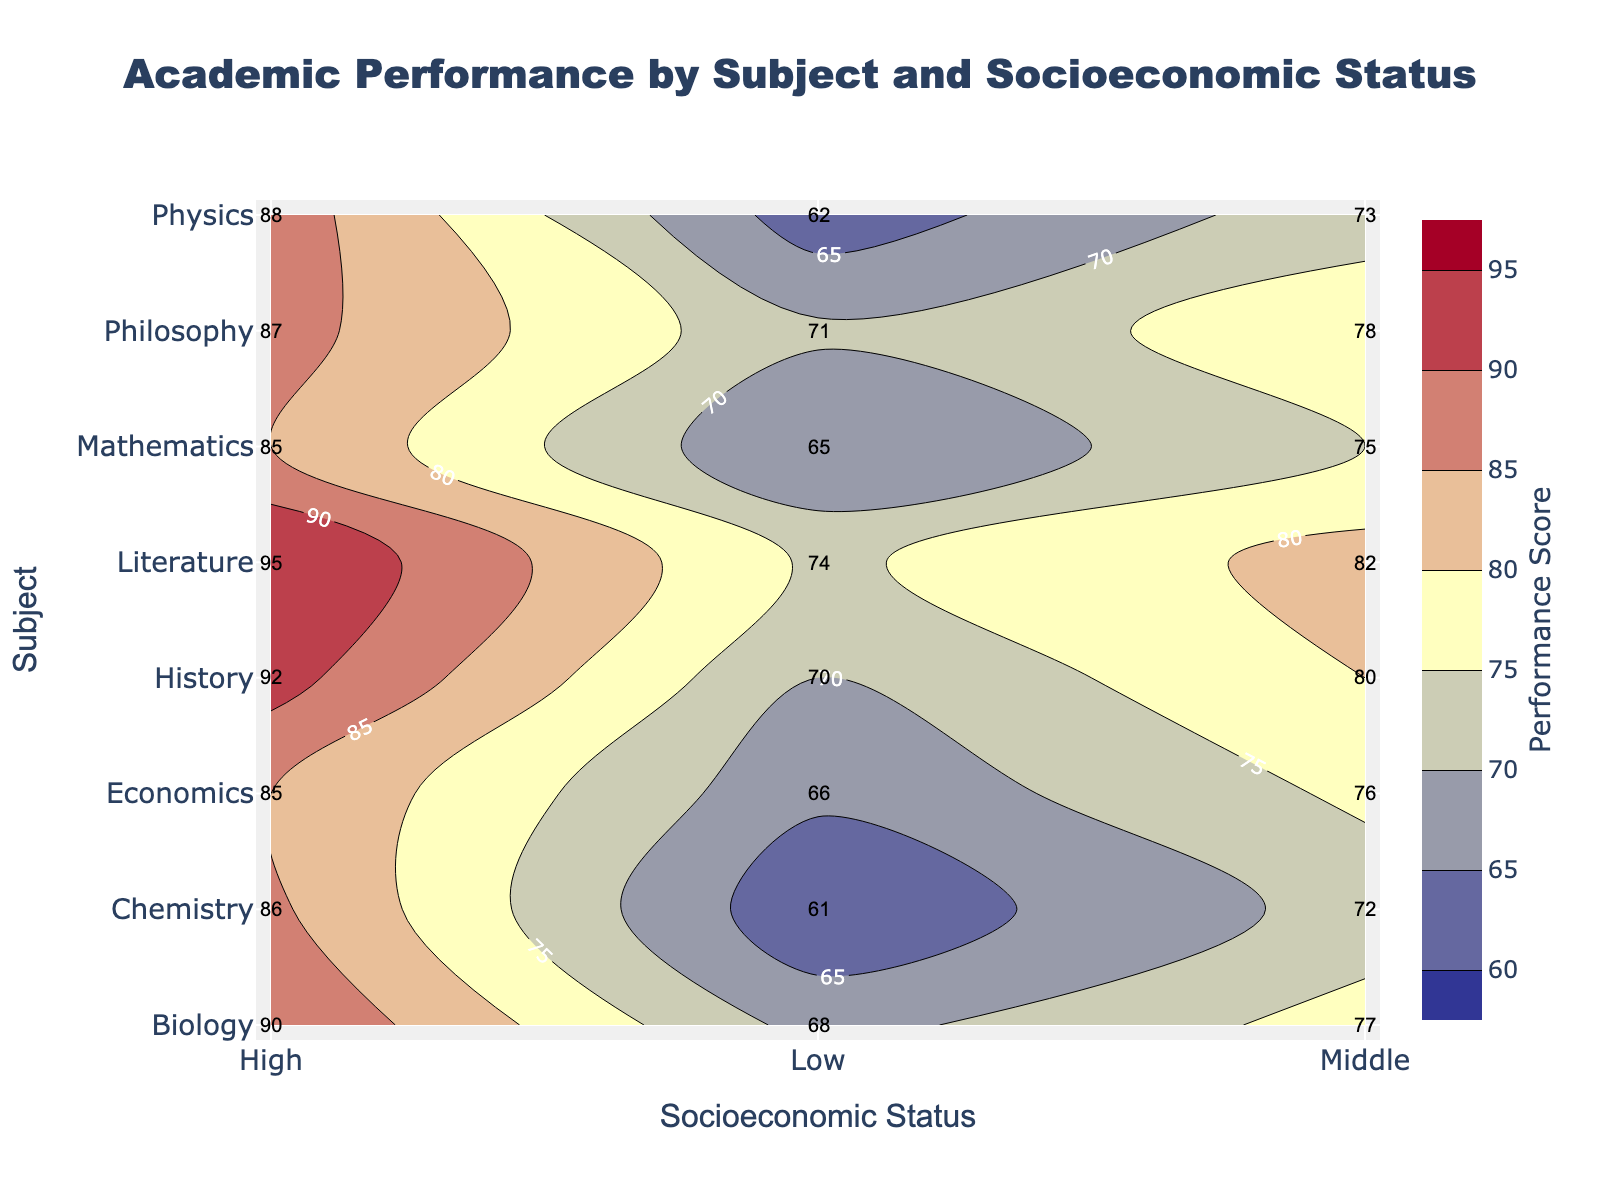What is the title of the figure? The title is usually located at the top of the figure, centered, and clearly labeled. In this figure, the title is "Academic Performance by Subject and Socioeconomic Status".
Answer: Academic Performance by Subject and Socioeconomic Status What are the x-axis and y-axis labels? The x-axis and y-axis labels are typically found near the respective axes. The x-axis is labeled "Socioeconomic Status," and the y-axis is labeled "Subject."
Answer: Socioeconomic Status, Subject What is the highest performance score observed in the figure? By looking for the highest contour label in the figure, which corresponds to the maximum value, we see that the highest performance score is 95 in the field of Literature for the High socioeconomic status.
Answer: 95 Which subject shows the least performance score for low socioeconomic status? By examining the contour plot for the "Low" socioeconomic status and comparing the values, Chemistry shows the least performance score, which is 61.
Answer: Chemistry Which socioeconomic status has the largest range of performance scores across all subjects? Calculate the performance score range for each socioeconomic status. For "Low": [70 (History) - 61 (Chemistry)] = 9. For "Middle": [82 (Literature) - 72 (Chemistry)] = 10. For "High": [95 (Literature) - 85 (Mathematics, Economics)] = 10. Both "Middle" and "High" have a range of 10.
Answer: Middle, High What is the overall trend in academic performance across different socioeconomic statuses? Observing the contour lines, the performance scores show a general upward trend from Low to High socioeconomic status across all subjects, meaning students from higher socioeconomic backgrounds tend to perform better academically.
Answer: Upward trend Between History and Physics, which subject shows the greater improvement in performance score moving from low to high socioeconomic status? The improvement in History is from 70 to 92, an increase of 22 points. In Physics, the increase is from 62 to 88, an increase of 26 points. Physics shows the greater improvement.
Answer: Physics How does the performance in Mathematics compare to Literature for middle socioeconomic status? For middle socioeconomic status, Mathematics has a score of 75, while Literature has a score of 82. Literature has a higher performance score.
Answer: Literature What is the average performance score for low socioeconomic status across all subjects? Sum the scores for low socioeconomic status (65 + 62 + 68 + 61 + 70 + 74 + 71 + 66) and divide by the number of scores (8). [(65 + 62 + 68 + 61 + 70 + 74 + 71 + 66)/8] = 537 / 8 = 67.125
Answer: 67.125 In which subject does socioeconomic status have the smallest impact on performance scores? Find the subject with the smallest difference between the highest and lowest socioeconomic status scores. Mathematics: 85-65=20, Physics: 88-62=26, Biology: 90-68=22, Chemistry: 86-61=25, History: 92-70=22, Literature: 95-74=21, Philosophy: 87-71=16, Economics: 85-66=19. The smallest impact is in Philosophy with a difference of 16.
Answer: Philosophy 